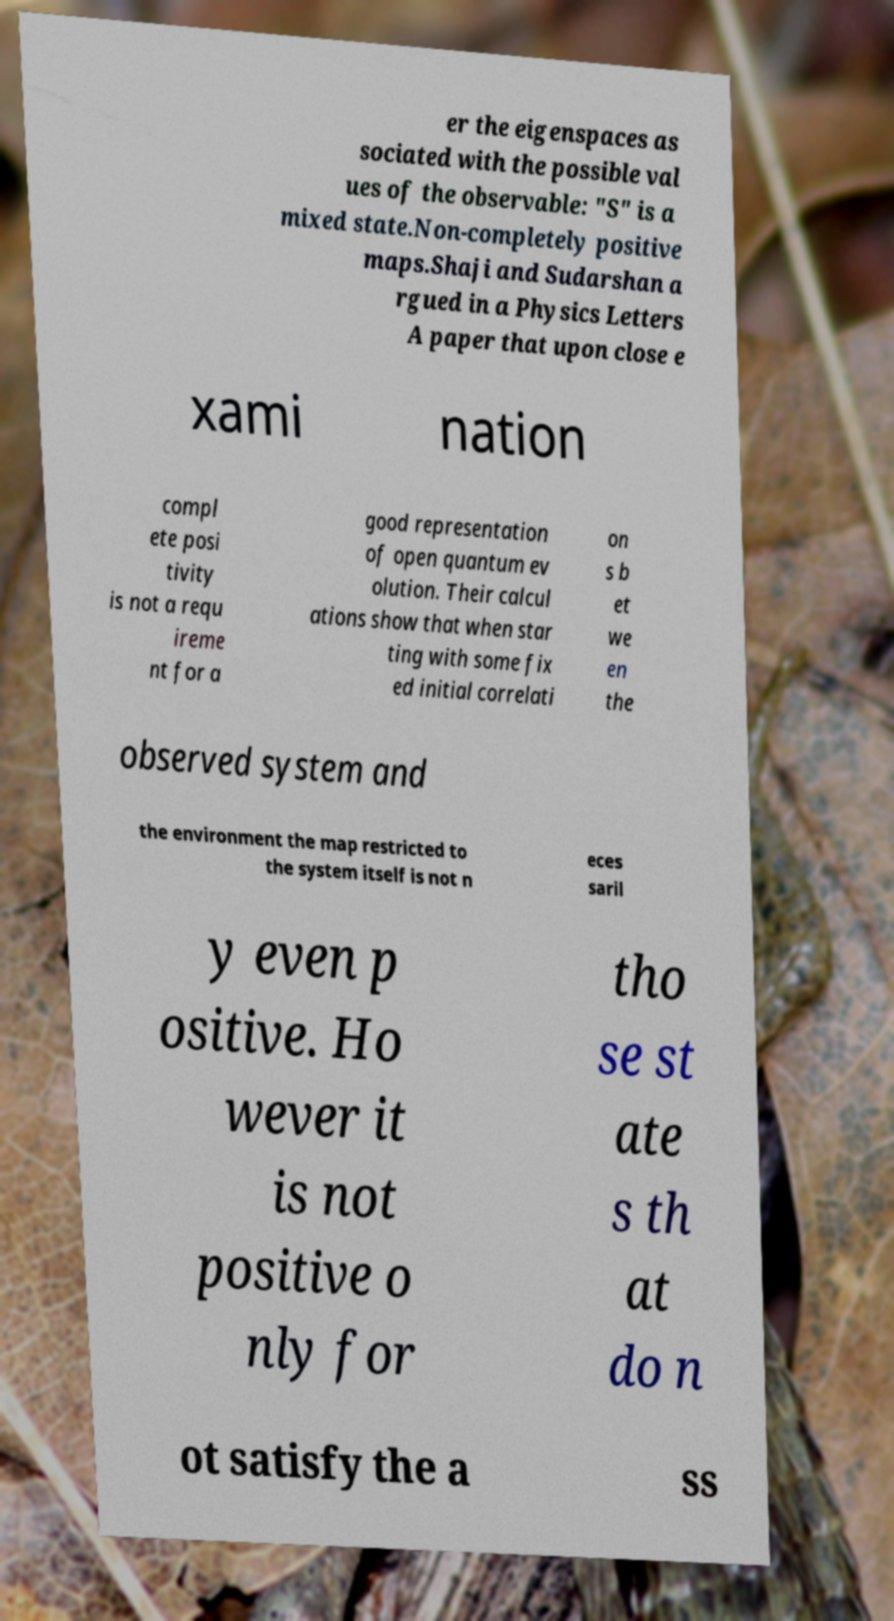Could you extract and type out the text from this image? er the eigenspaces as sociated with the possible val ues of the observable: "S" is a mixed state.Non-completely positive maps.Shaji and Sudarshan a rgued in a Physics Letters A paper that upon close e xami nation compl ete posi tivity is not a requ ireme nt for a good representation of open quantum ev olution. Their calcul ations show that when star ting with some fix ed initial correlati on s b et we en the observed system and the environment the map restricted to the system itself is not n eces saril y even p ositive. Ho wever it is not positive o nly for tho se st ate s th at do n ot satisfy the a ss 